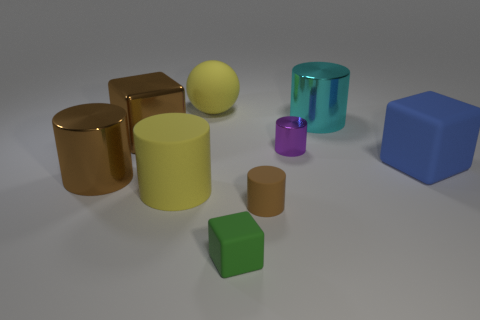Subtract all large blocks. How many blocks are left? 1 Add 1 big brown spheres. How many objects exist? 10 Add 7 brown matte objects. How many brown matte objects are left? 8 Add 5 brown shiny objects. How many brown shiny objects exist? 7 Subtract all brown cubes. How many cubes are left? 2 Subtract 0 blue cylinders. How many objects are left? 9 Subtract all cylinders. How many objects are left? 4 Subtract 1 balls. How many balls are left? 0 Subtract all green spheres. Subtract all blue cubes. How many spheres are left? 1 Subtract all gray blocks. How many cyan cylinders are left? 1 